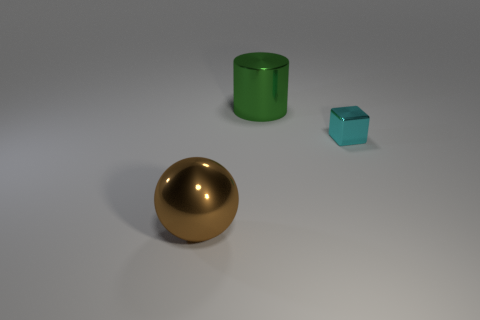Are the large object that is left of the large cylinder and the cylinder made of the same material?
Your response must be concise. Yes. How many other objects are the same material as the small cyan thing?
Give a very brief answer. 2. What is the material of the other object that is the same size as the brown metallic object?
Ensure brevity in your answer.  Metal. The brown object that is the same size as the cylinder is what shape?
Provide a short and direct response. Sphere. Does the big cylinder behind the tiny metal block have the same material as the large thing that is in front of the metal cylinder?
Offer a very short reply. Yes. Is there a large metal thing in front of the thing left of the green thing?
Make the answer very short. No. There is a big cylinder that is the same material as the cyan block; what is its color?
Ensure brevity in your answer.  Green. Are there more small objects than yellow matte things?
Ensure brevity in your answer.  Yes. How many objects are big objects that are in front of the metallic block or small yellow rubber things?
Your answer should be very brief. 1. Is there a brown matte cylinder that has the same size as the brown object?
Make the answer very short. No. 